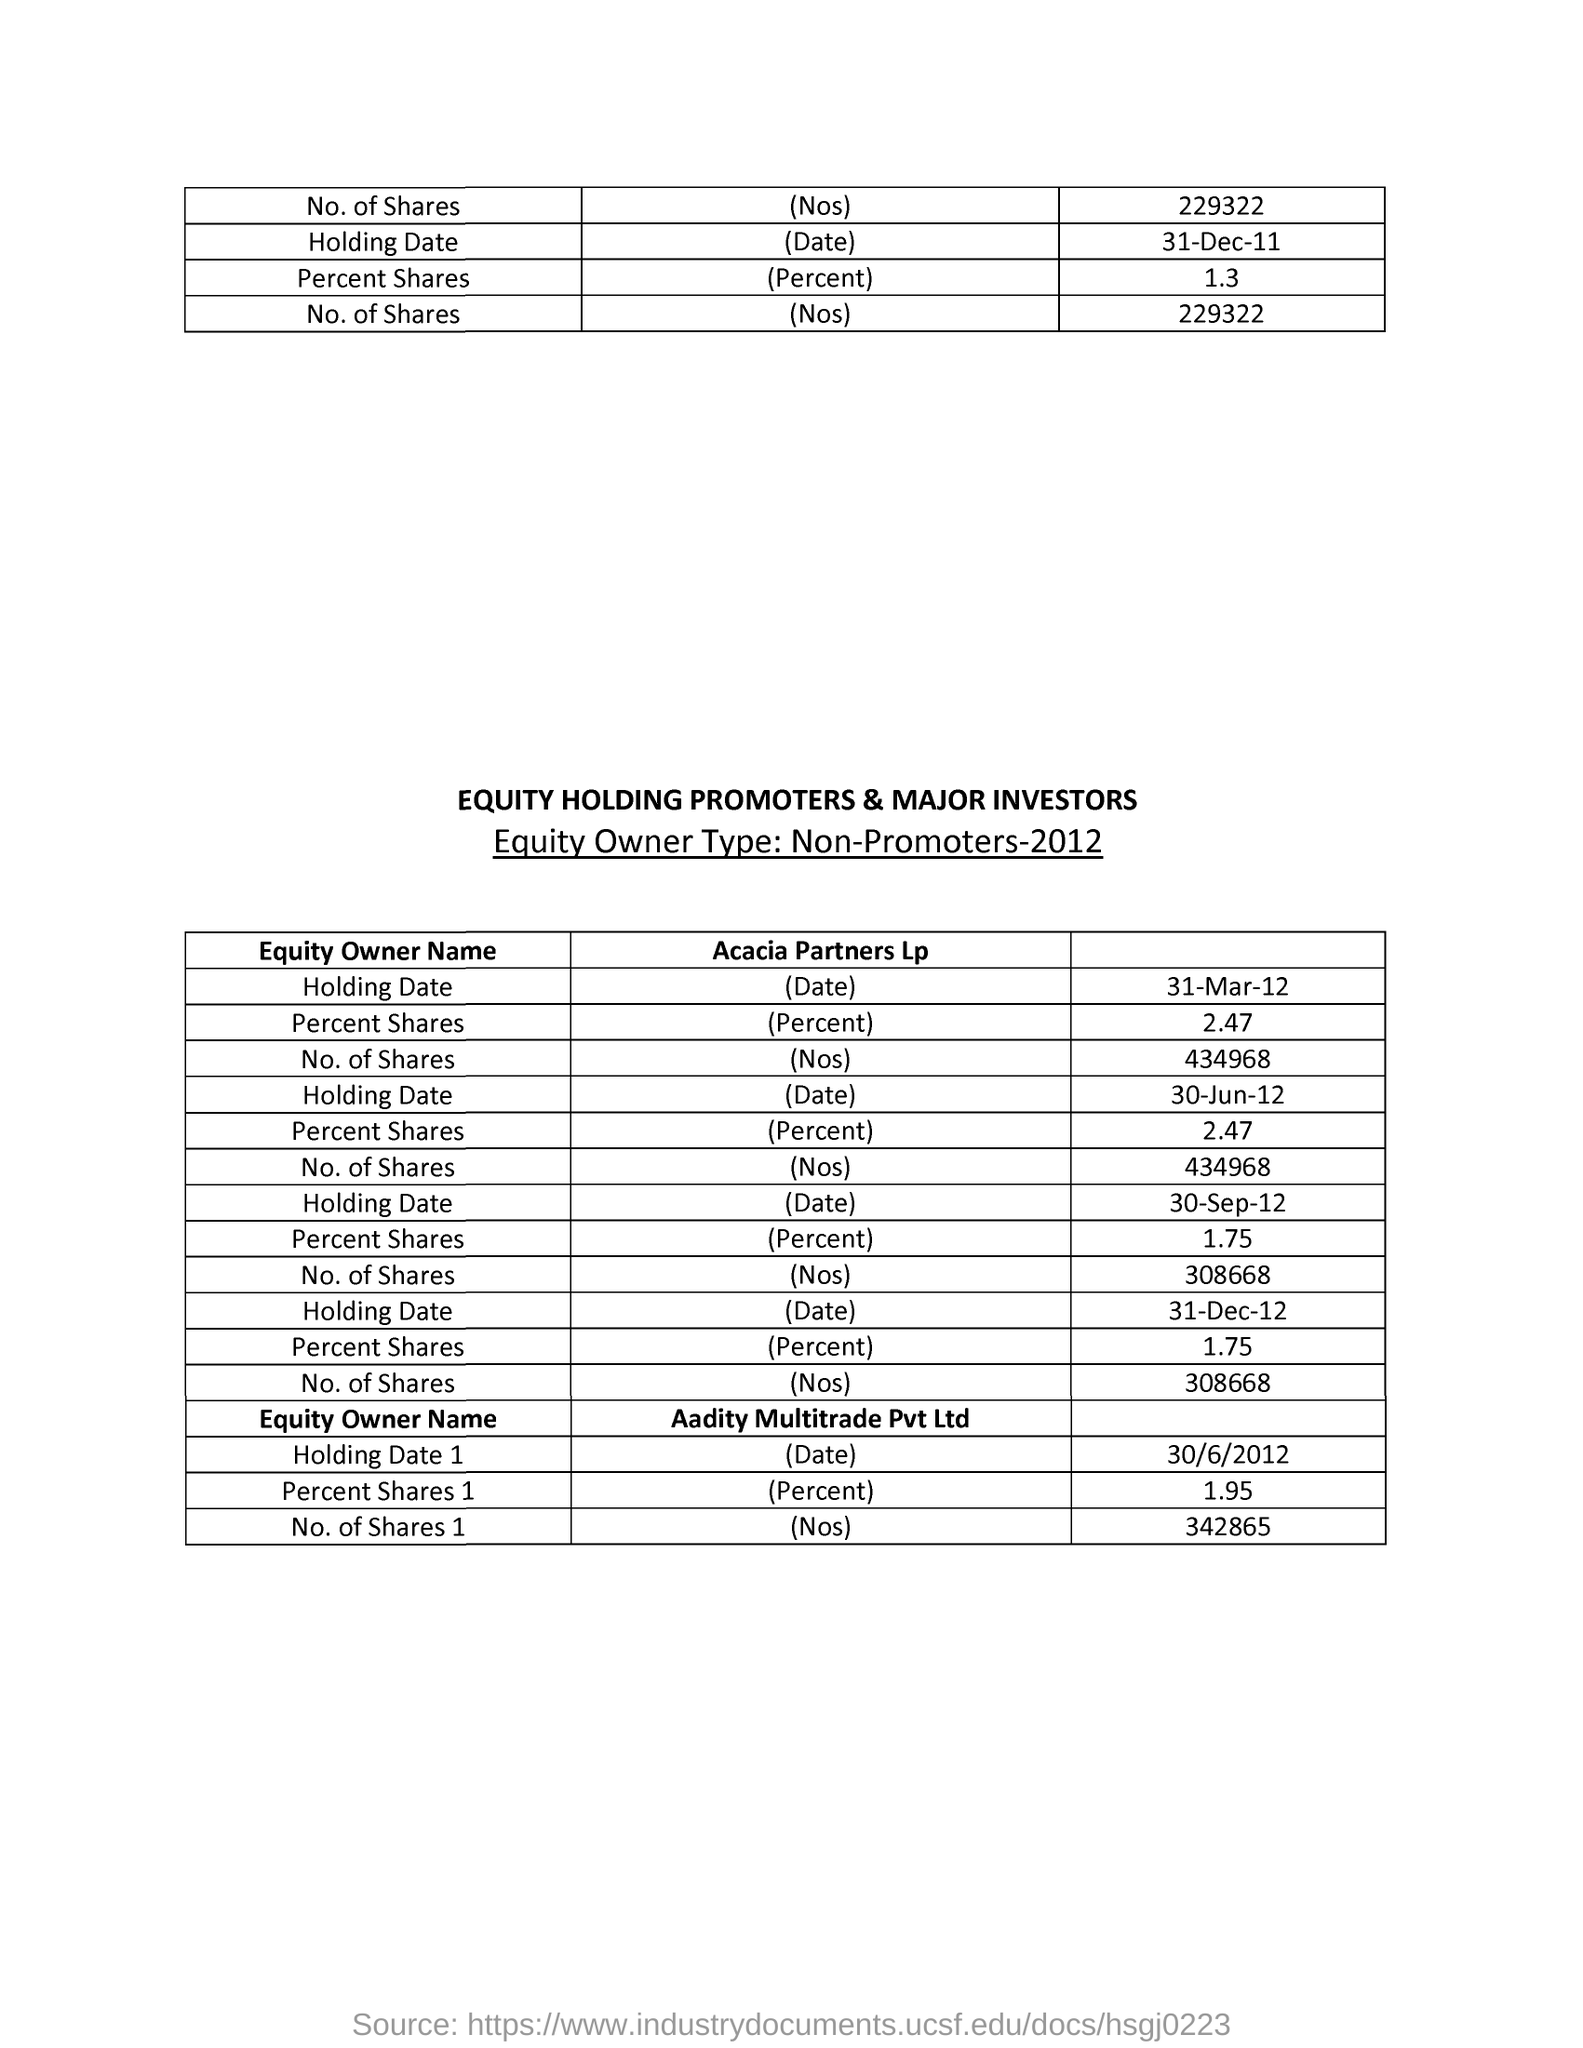Give some essential details in this illustration. The total number of shares in Aadity Multitrade Pvt Ltd is 342865. According to our records, Aaditya Multitrade Pvt Ltd holds 1.95% of the company's shares. 